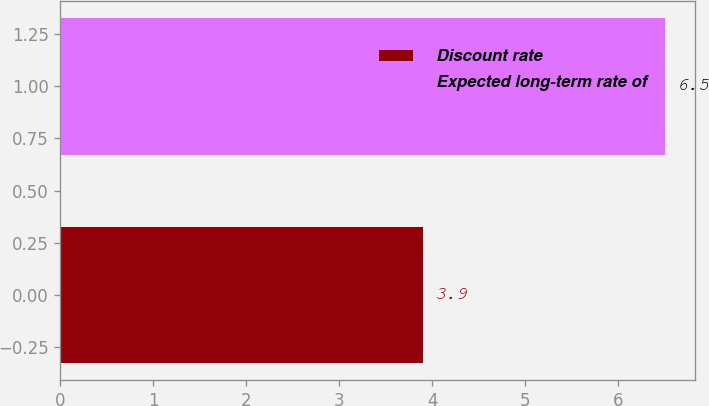Convert chart to OTSL. <chart><loc_0><loc_0><loc_500><loc_500><bar_chart><fcel>Discount rate<fcel>Expected long-term rate of<nl><fcel>3.9<fcel>6.5<nl></chart> 